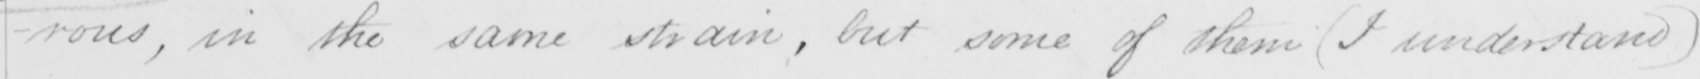Can you read and transcribe this handwriting? -rous , in the same strain , but some of them  ( I understand ) 